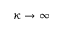<formula> <loc_0><loc_0><loc_500><loc_500>\kappa \to \infty</formula> 